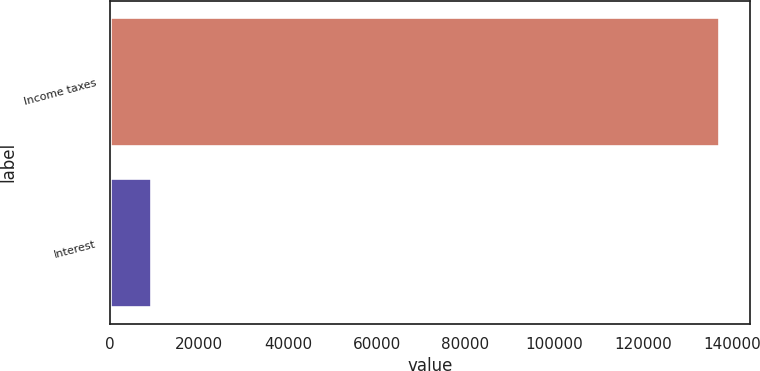<chart> <loc_0><loc_0><loc_500><loc_500><bar_chart><fcel>Income taxes<fcel>Interest<nl><fcel>137149<fcel>9199<nl></chart> 